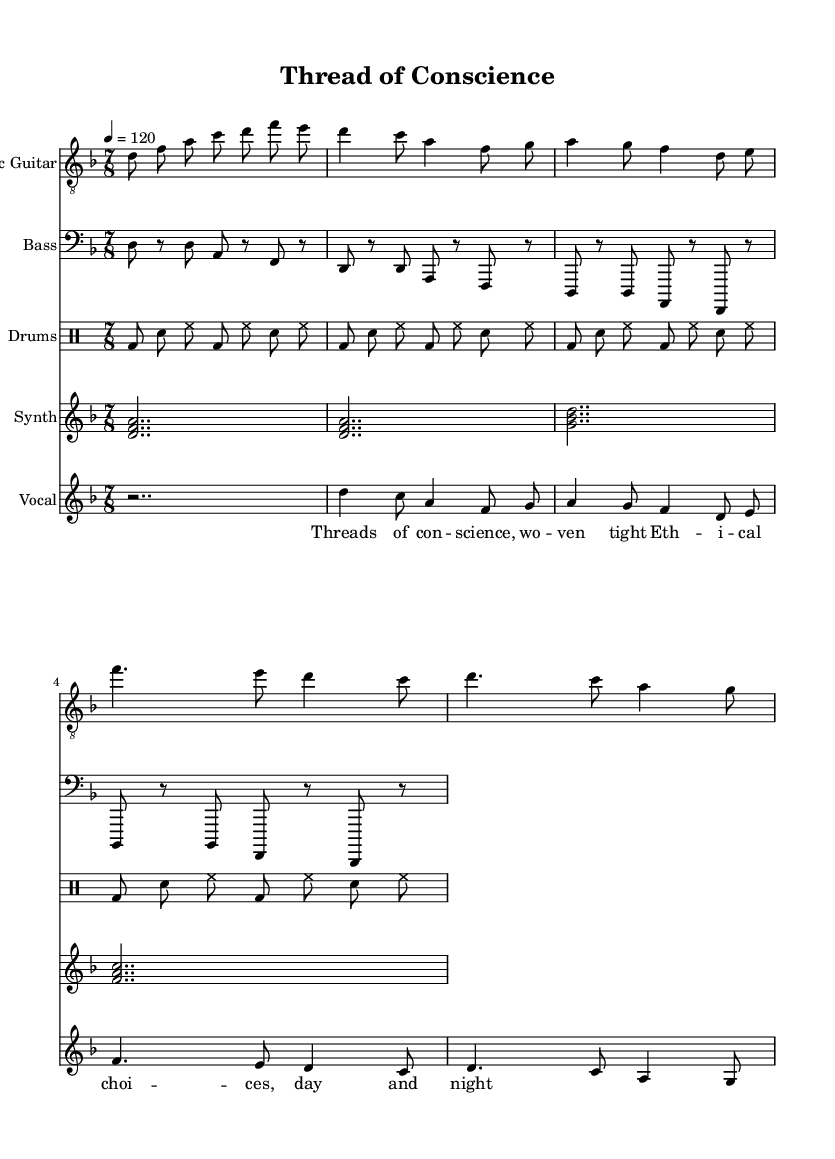What is the key signature of this music? The key signature is indicated at the beginning of the staff. Here, the key signature shows two flats, which corresponds to D minor.
Answer: D minor What is the time signature of this music? The time signature is indicated after the key signature and shows a 7 over 8, meaning there are seven eighth notes per measure.
Answer: 7/8 What is the tempo marking for this piece? The tempo marking is shown in the form of a number and a note value; it specifies 120 beats per minute, which is indicated in the tempo marking.
Answer: 120 How many measures are in the electric guitar part? The electric guitar part consists of a series of notes grouped into measures. By counting the measures visually from the start to the end, it is evident that there are eight measures in total.
Answer: eight What note does the vocal melody start on? The vocal melody starts on D, which is indicated as the first note of the vocal staff.
Answer: D Which instrument has the clef "bass"? The bass guitar part is specifically marked with a bass clef at the beginning of its staff, indicating it is written for lower pitches.
Answer: Bass How many different instruments are indicated in the score? The score lists multiple staves for different instruments, counting each distinct staff. The electric guitar, bass guitar, drums, synth, and vocal part are all included, leading to a total of five instruments.
Answer: five 